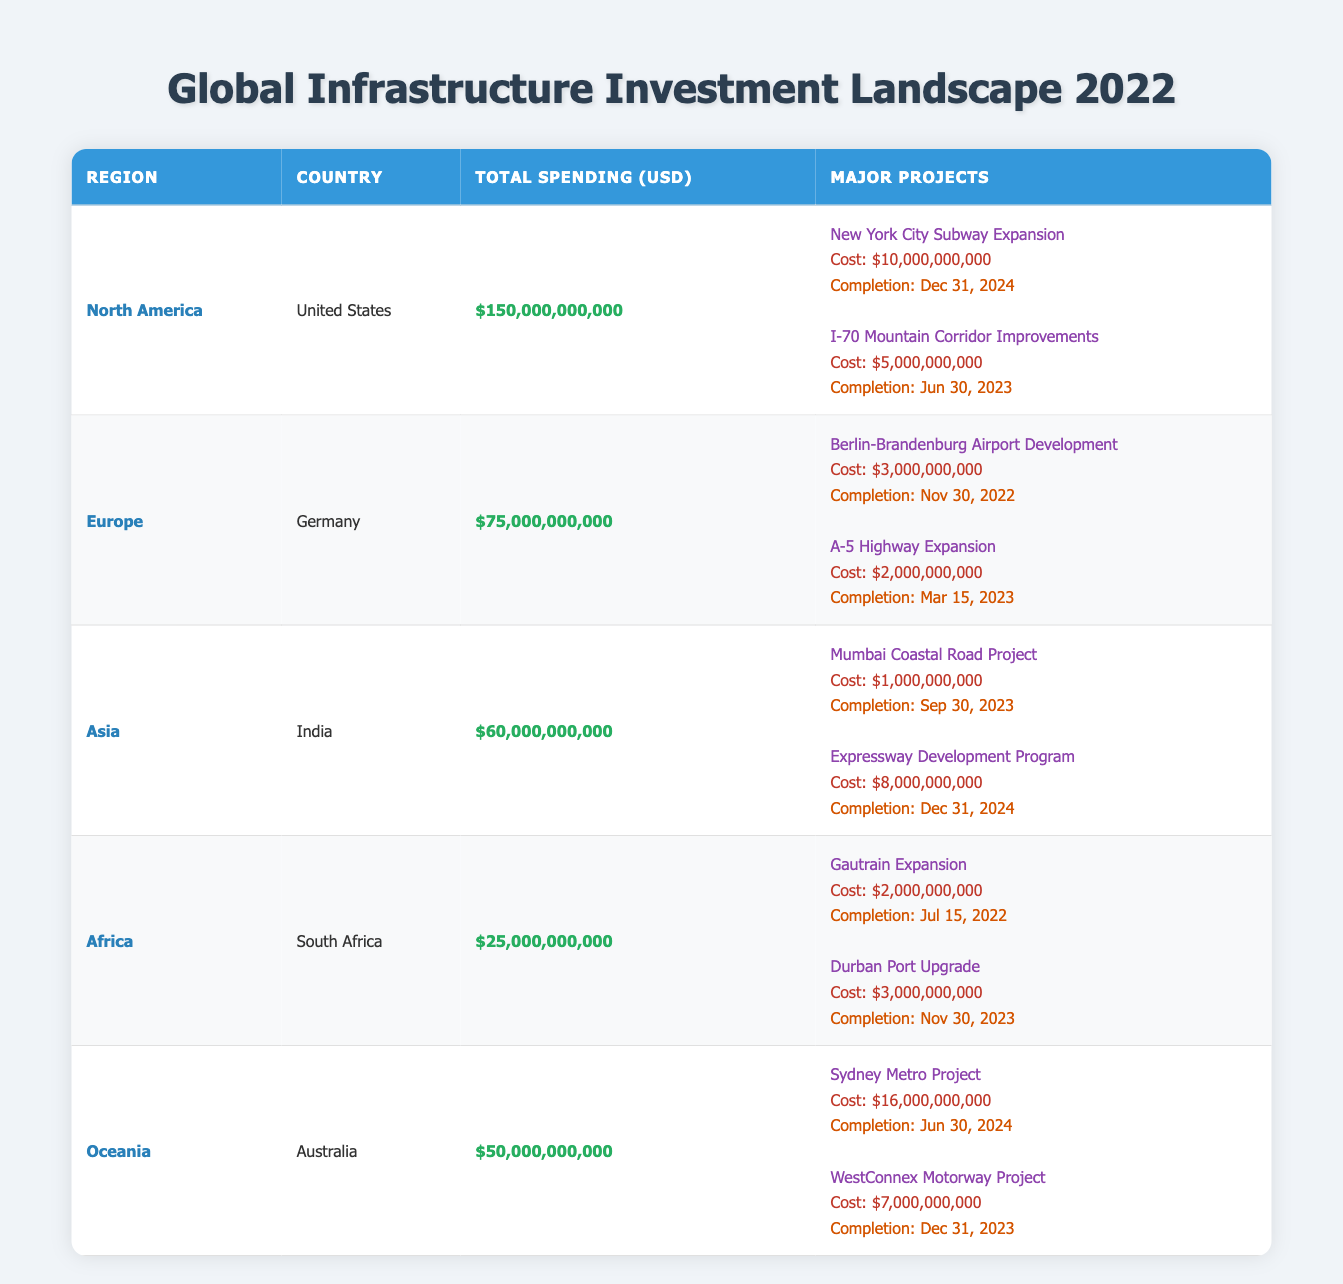What is the total public spending on infrastructure projects in North America? The table indicates that the total public spending on infrastructure projects in North America is listed alongside the region and country. For North America (United States), the total spending is $150,000,000,000.
Answer: $150,000,000,000 Which country in Europe had the highest spending on infrastructure projects? The table shows that Germany is the only country listed under Europe with a total spending of $75,000,000,000, which is higher than any other country not listed.
Answer: Germany How much more did North America spend on infrastructure projects compared to Africa? To find this value, subtract the total spending of Africa from North America's total. North America spent $150,000,000,000 while Africa's spending was $25,000,000,000. The difference is $150,000,000,000 - $25,000,000,000 = $125,000,000,000.
Answer: $125,000,000,000 Did any projects in South Africa complete before 2023? Checking the completion dates for South Africa's major projects: Gautrain Expansion completed on July 15, 2022, while Durban Port Upgrade is due to complete on November 30, 2023. Since one project was completed before 2023, the answer is yes.
Answer: Yes What is the total cost of major projects planned for completion in 2024 across all regions? To calculate the total cost of the major projects set for completion in 2024, we look for projects in all regions whose completion date is in that year. The projects are the NYC Subway Expansion ($10,000,000,000), Expressway Development Program ($8,000,000,000), Sydney Metro Project ($16,000,000,000). Adding these costs: $10,000,000,000 + $8,000,000,000 + $16,000,000,000 = $34,000,000,000.
Answer: $34,000,000,000 Does Oceania have the highest number of major projects compared to other regions? From the table, Oceania has two major projects listed. North America has two projects as well, Europe and Africa also have two projects each while Asia has two as well. Since all regions have an equal number of two major projects, the answer is no.
Answer: No 